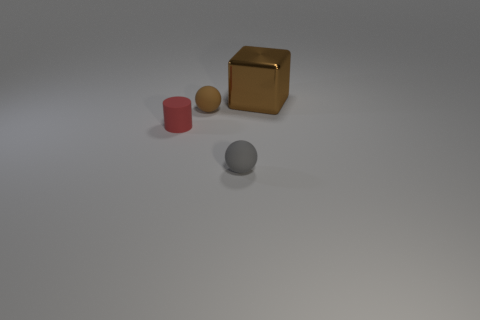How many other things are the same color as the cylinder?
Your response must be concise. 0. What number of brown things are big cubes or rubber cylinders?
Make the answer very short. 1. What size is the red matte thing?
Provide a short and direct response. Small. What number of rubber objects are either big red balls or tiny gray balls?
Offer a very short reply. 1. Are there fewer brown rubber balls than yellow cylinders?
Offer a very short reply. No. What number of other objects are there of the same material as the small cylinder?
Provide a succinct answer. 2. What size is the other matte thing that is the same shape as the tiny brown rubber thing?
Your answer should be compact. Small. Is the brown object that is left of the large thing made of the same material as the small thing in front of the small red cylinder?
Provide a short and direct response. Yes. Is the number of big brown blocks that are right of the small gray thing less than the number of brown matte spheres?
Ensure brevity in your answer.  No. Is there anything else that is the same shape as the large brown shiny thing?
Keep it short and to the point. No. 